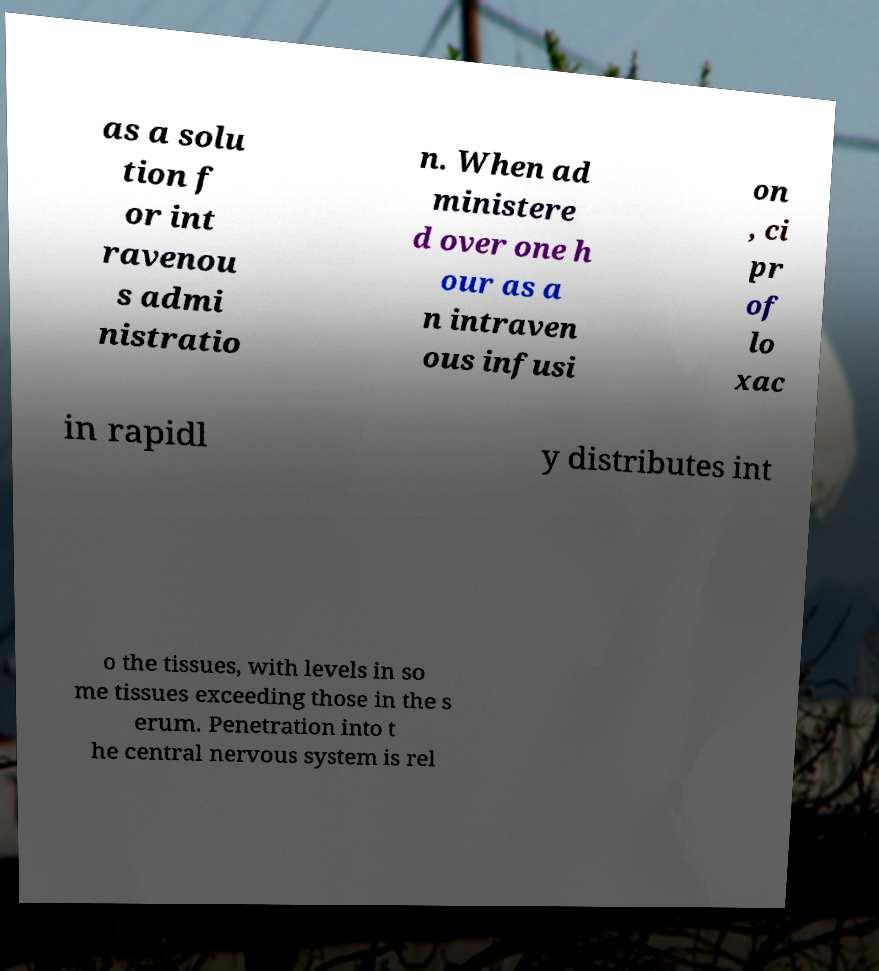Can you accurately transcribe the text from the provided image for me? as a solu tion f or int ravenou s admi nistratio n. When ad ministere d over one h our as a n intraven ous infusi on , ci pr of lo xac in rapidl y distributes int o the tissues, with levels in so me tissues exceeding those in the s erum. Penetration into t he central nervous system is rel 